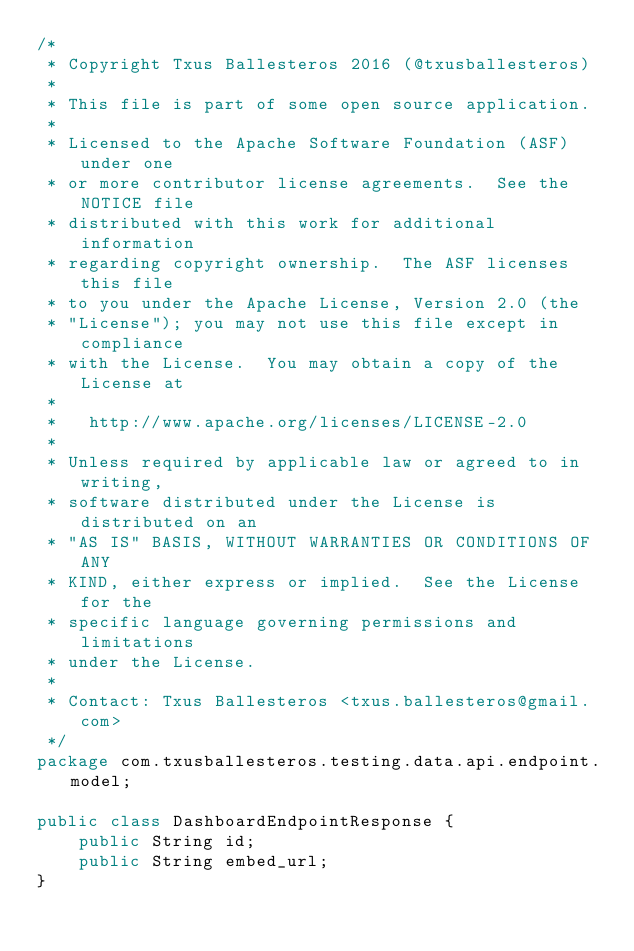<code> <loc_0><loc_0><loc_500><loc_500><_Java_>/*
 * Copyright Txus Ballesteros 2016 (@txusballesteros)
 *
 * This file is part of some open source application.
 *
 * Licensed to the Apache Software Foundation (ASF) under one
 * or more contributor license agreements.  See the NOTICE file
 * distributed with this work for additional information
 * regarding copyright ownership.  The ASF licenses this file
 * to you under the Apache License, Version 2.0 (the
 * "License"); you may not use this file except in compliance
 * with the License.  You may obtain a copy of the License at
 *
 *   http://www.apache.org/licenses/LICENSE-2.0
 *
 * Unless required by applicable law or agreed to in writing,
 * software distributed under the License is distributed on an
 * "AS IS" BASIS, WITHOUT WARRANTIES OR CONDITIONS OF ANY
 * KIND, either express or implied.  See the License for the
 * specific language governing permissions and limitations
 * under the License.
 *
 * Contact: Txus Ballesteros <txus.ballesteros@gmail.com>
 */
package com.txusballesteros.testing.data.api.endpoint.model;

public class DashboardEndpointResponse {
    public String id;
    public String embed_url;
}
</code> 